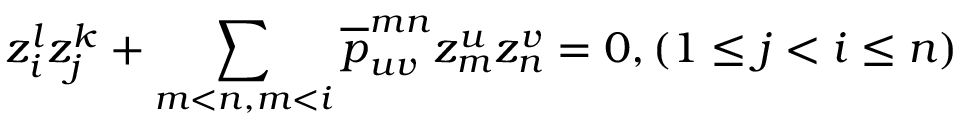<formula> <loc_0><loc_0><loc_500><loc_500>z _ { i } ^ { l } z _ { j } ^ { k } + \sum _ { m < n , m < i } \overline { p } _ { u v } ^ { m n } z _ { m } ^ { u } z _ { n } ^ { v } = 0 , ( 1 \leq j < i \leq n )</formula> 